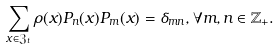<formula> <loc_0><loc_0><loc_500><loc_500>\sum _ { x \in \mathfrak { Z } _ { t } } \rho ( x ) P _ { n } ( x ) P _ { m } ( x ) = \delta _ { m n } , \forall m , n \in \mathbb { Z } _ { + } .</formula> 